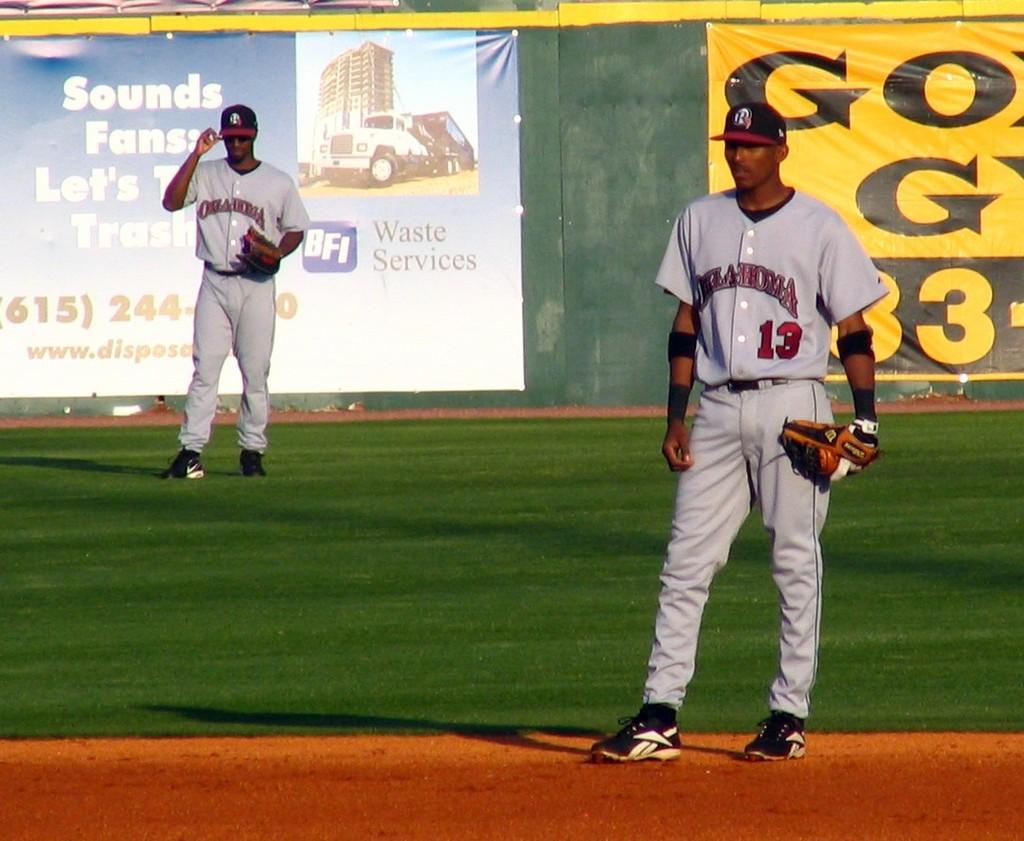What is the number in the back?
Provide a succinct answer. 3. 